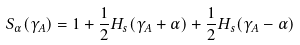<formula> <loc_0><loc_0><loc_500><loc_500>S _ { \alpha } ( \gamma _ { A } ) = 1 + \frac { 1 } { 2 } H _ { s } ( \gamma _ { A } + \alpha ) + \frac { 1 } { 2 } H _ { s } ( \gamma _ { A } - \alpha )</formula> 